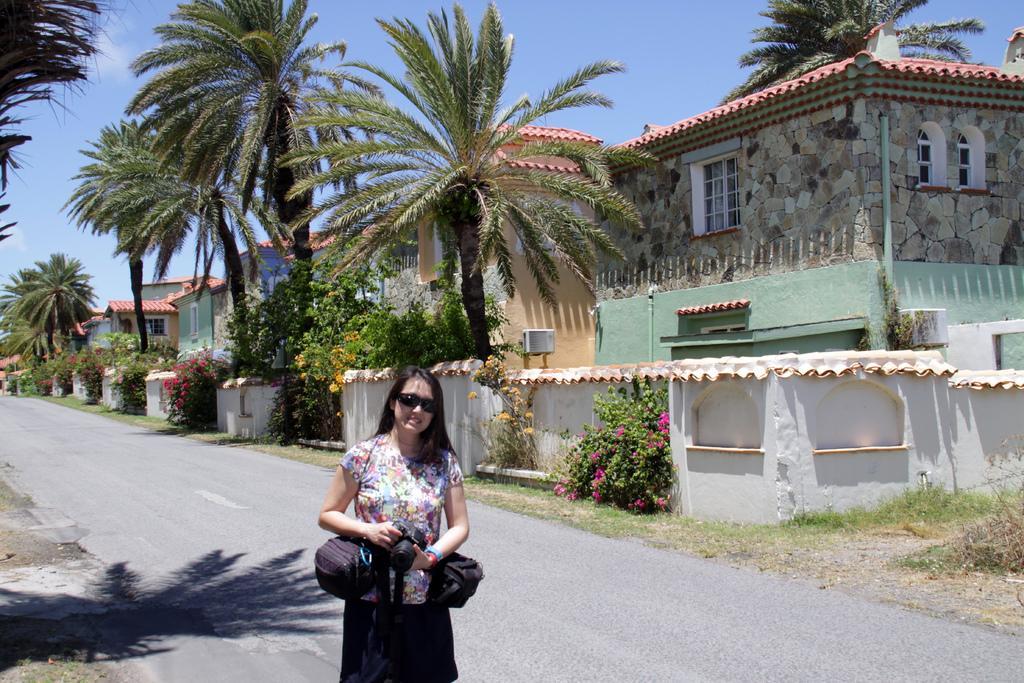Could you give a brief overview of what you see in this image? In this picture we can see a woman, she wore spectacles and she is holding a camera, in the background we can see few trees, flowers and buildings, and also we can see few bags. 